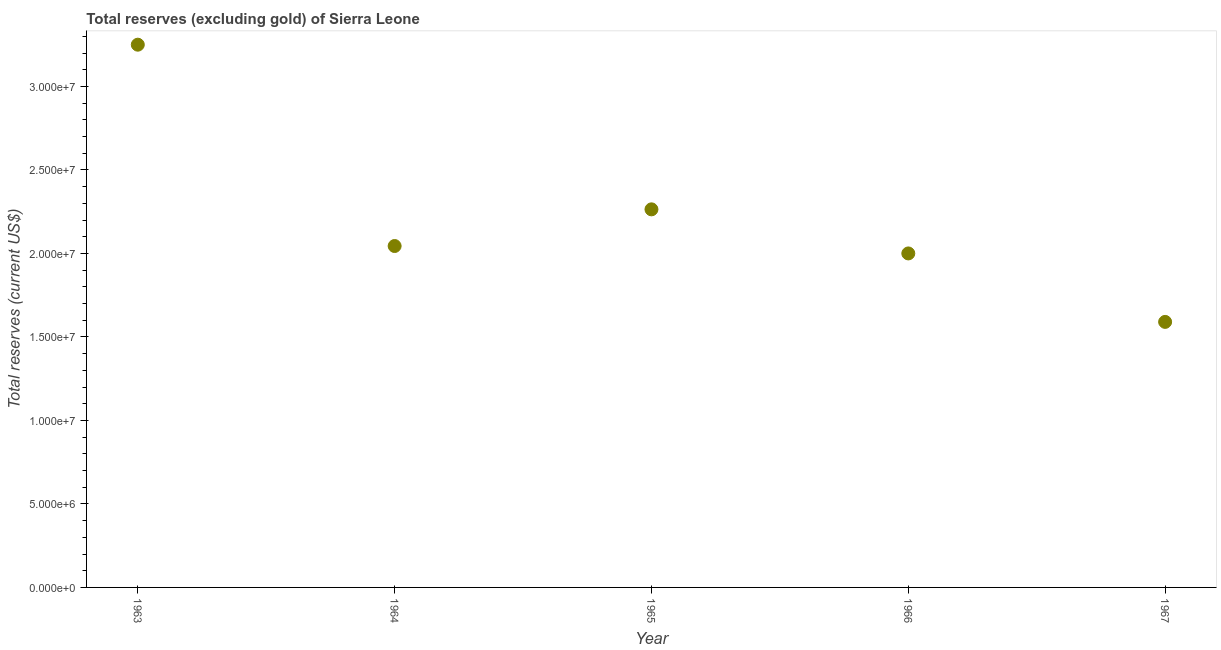What is the total reserves (excluding gold) in 1963?
Your response must be concise. 3.25e+07. Across all years, what is the maximum total reserves (excluding gold)?
Your answer should be compact. 3.25e+07. Across all years, what is the minimum total reserves (excluding gold)?
Provide a short and direct response. 1.59e+07. In which year was the total reserves (excluding gold) maximum?
Your response must be concise. 1963. In which year was the total reserves (excluding gold) minimum?
Give a very brief answer. 1967. What is the sum of the total reserves (excluding gold)?
Your answer should be very brief. 1.11e+08. What is the difference between the total reserves (excluding gold) in 1963 and 1966?
Give a very brief answer. 1.25e+07. What is the average total reserves (excluding gold) per year?
Your answer should be compact. 2.23e+07. What is the median total reserves (excluding gold)?
Your answer should be very brief. 2.04e+07. What is the ratio of the total reserves (excluding gold) in 1965 to that in 1966?
Offer a very short reply. 1.13. Is the difference between the total reserves (excluding gold) in 1965 and 1967 greater than the difference between any two years?
Your response must be concise. No. What is the difference between the highest and the second highest total reserves (excluding gold)?
Ensure brevity in your answer.  9.86e+06. Is the sum of the total reserves (excluding gold) in 1964 and 1966 greater than the maximum total reserves (excluding gold) across all years?
Ensure brevity in your answer.  Yes. What is the difference between the highest and the lowest total reserves (excluding gold)?
Keep it short and to the point. 1.66e+07. Does the total reserves (excluding gold) monotonically increase over the years?
Provide a succinct answer. No. How many dotlines are there?
Your answer should be very brief. 1. How many years are there in the graph?
Your answer should be compact. 5. Are the values on the major ticks of Y-axis written in scientific E-notation?
Provide a succinct answer. Yes. Does the graph contain any zero values?
Provide a short and direct response. No. What is the title of the graph?
Ensure brevity in your answer.  Total reserves (excluding gold) of Sierra Leone. What is the label or title of the Y-axis?
Ensure brevity in your answer.  Total reserves (current US$). What is the Total reserves (current US$) in 1963?
Your answer should be very brief. 3.25e+07. What is the Total reserves (current US$) in 1964?
Keep it short and to the point. 2.04e+07. What is the Total reserves (current US$) in 1965?
Your response must be concise. 2.26e+07. What is the Total reserves (current US$) in 1966?
Offer a terse response. 2.00e+07. What is the Total reserves (current US$) in 1967?
Give a very brief answer. 1.59e+07. What is the difference between the Total reserves (current US$) in 1963 and 1964?
Provide a succinct answer. 1.21e+07. What is the difference between the Total reserves (current US$) in 1963 and 1965?
Offer a very short reply. 9.86e+06. What is the difference between the Total reserves (current US$) in 1963 and 1966?
Keep it short and to the point. 1.25e+07. What is the difference between the Total reserves (current US$) in 1963 and 1967?
Keep it short and to the point. 1.66e+07. What is the difference between the Total reserves (current US$) in 1964 and 1965?
Your answer should be compact. -2.20e+06. What is the difference between the Total reserves (current US$) in 1964 and 1966?
Your answer should be very brief. 4.44e+05. What is the difference between the Total reserves (current US$) in 1964 and 1967?
Offer a very short reply. 4.54e+06. What is the difference between the Total reserves (current US$) in 1965 and 1966?
Offer a very short reply. 2.64e+06. What is the difference between the Total reserves (current US$) in 1965 and 1967?
Provide a succinct answer. 6.74e+06. What is the difference between the Total reserves (current US$) in 1966 and 1967?
Your answer should be compact. 4.10e+06. What is the ratio of the Total reserves (current US$) in 1963 to that in 1964?
Your answer should be very brief. 1.59. What is the ratio of the Total reserves (current US$) in 1963 to that in 1965?
Provide a succinct answer. 1.44. What is the ratio of the Total reserves (current US$) in 1963 to that in 1966?
Ensure brevity in your answer.  1.62. What is the ratio of the Total reserves (current US$) in 1963 to that in 1967?
Offer a very short reply. 2.04. What is the ratio of the Total reserves (current US$) in 1964 to that in 1965?
Make the answer very short. 0.9. What is the ratio of the Total reserves (current US$) in 1964 to that in 1967?
Your answer should be compact. 1.29. What is the ratio of the Total reserves (current US$) in 1965 to that in 1966?
Your answer should be compact. 1.13. What is the ratio of the Total reserves (current US$) in 1965 to that in 1967?
Keep it short and to the point. 1.42. What is the ratio of the Total reserves (current US$) in 1966 to that in 1967?
Offer a very short reply. 1.26. 